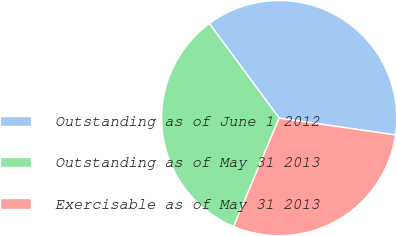Convert chart. <chart><loc_0><loc_0><loc_500><loc_500><pie_chart><fcel>Outstanding as of June 1 2012<fcel>Outstanding as of May 31 2013<fcel>Exercisable as of May 31 2013<nl><fcel>37.42%<fcel>33.55%<fcel>29.03%<nl></chart> 